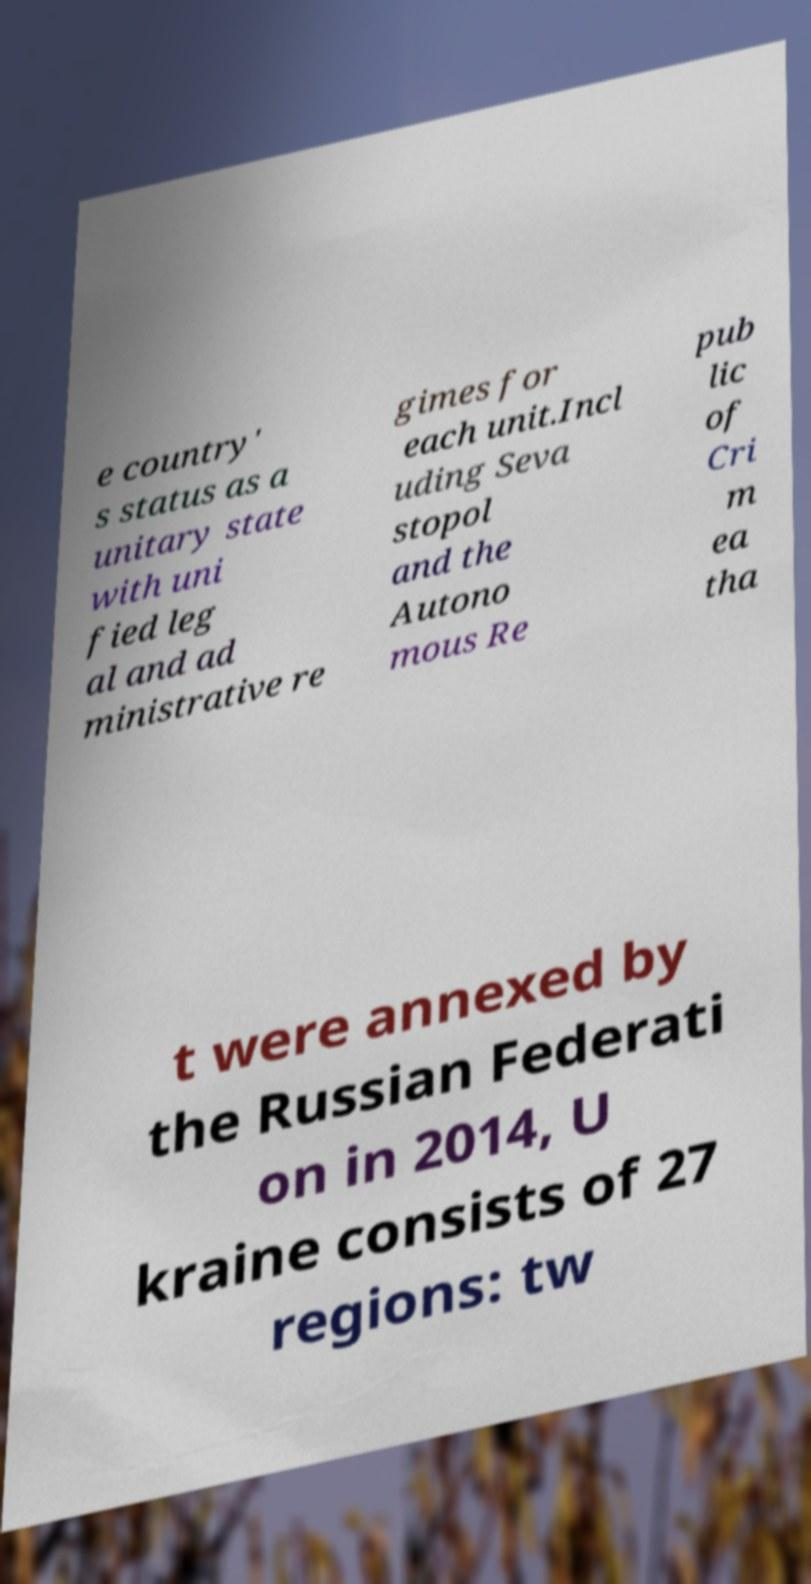I need the written content from this picture converted into text. Can you do that? e country' s status as a unitary state with uni fied leg al and ad ministrative re gimes for each unit.Incl uding Seva stopol and the Autono mous Re pub lic of Cri m ea tha t were annexed by the Russian Federati on in 2014, U kraine consists of 27 regions: tw 